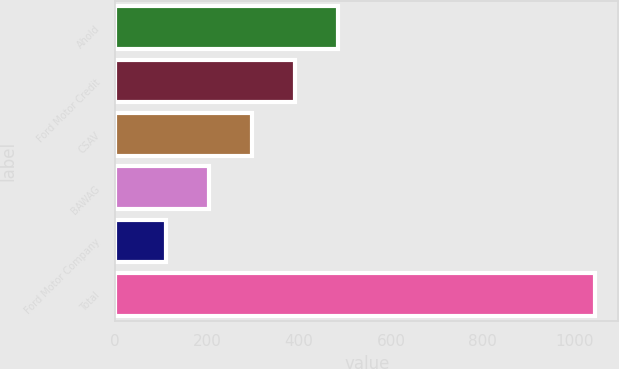Convert chart. <chart><loc_0><loc_0><loc_500><loc_500><bar_chart><fcel>Ahold<fcel>Ford Motor Credit<fcel>CSAV<fcel>BAWAG<fcel>Ford Motor Company<fcel>Total<nl><fcel>483.8<fcel>390.6<fcel>297.4<fcel>204.2<fcel>111<fcel>1043<nl></chart> 